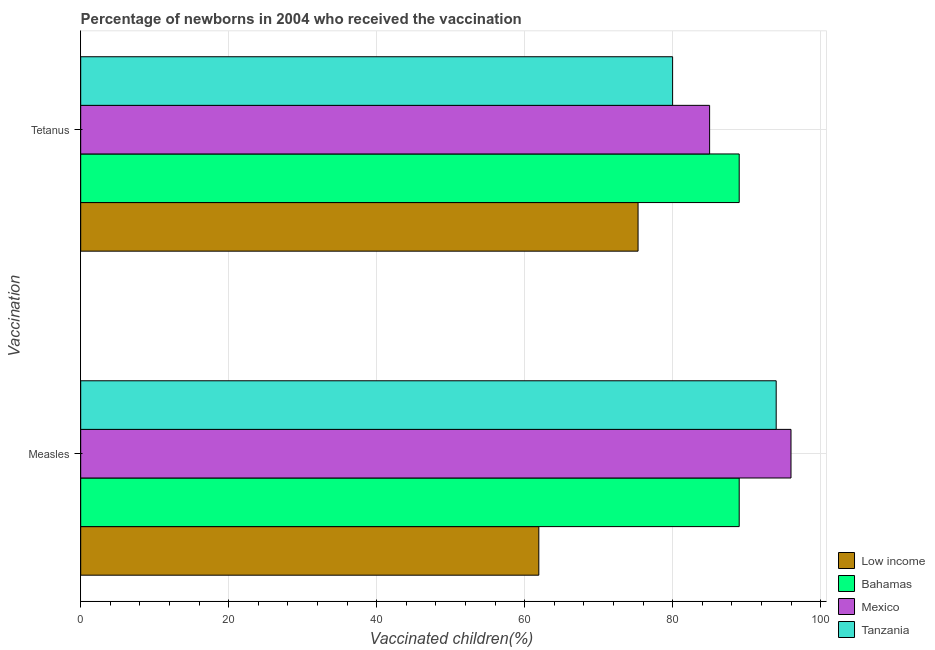How many different coloured bars are there?
Offer a terse response. 4. How many groups of bars are there?
Offer a very short reply. 2. Are the number of bars on each tick of the Y-axis equal?
Offer a terse response. Yes. What is the label of the 1st group of bars from the top?
Keep it short and to the point. Tetanus. What is the percentage of newborns who received vaccination for tetanus in Bahamas?
Give a very brief answer. 89. Across all countries, what is the maximum percentage of newborns who received vaccination for tetanus?
Keep it short and to the point. 89. Across all countries, what is the minimum percentage of newborns who received vaccination for tetanus?
Your answer should be very brief. 75.33. In which country was the percentage of newborns who received vaccination for measles minimum?
Ensure brevity in your answer.  Low income. What is the total percentage of newborns who received vaccination for tetanus in the graph?
Offer a terse response. 329.33. What is the difference between the percentage of newborns who received vaccination for tetanus in Mexico and that in Low income?
Your answer should be compact. 9.67. What is the difference between the percentage of newborns who received vaccination for measles in Mexico and the percentage of newborns who received vaccination for tetanus in Tanzania?
Your answer should be very brief. 16. What is the average percentage of newborns who received vaccination for tetanus per country?
Offer a terse response. 82.33. What is the difference between the percentage of newborns who received vaccination for tetanus and percentage of newborns who received vaccination for measles in Bahamas?
Your answer should be very brief. 0. What is the ratio of the percentage of newborns who received vaccination for measles in Low income to that in Bahamas?
Provide a succinct answer. 0.7. Is the percentage of newborns who received vaccination for tetanus in Low income less than that in Mexico?
Keep it short and to the point. Yes. In how many countries, is the percentage of newborns who received vaccination for tetanus greater than the average percentage of newborns who received vaccination for tetanus taken over all countries?
Offer a very short reply. 2. What does the 1st bar from the top in Tetanus represents?
Your answer should be very brief. Tanzania. What does the 2nd bar from the bottom in Measles represents?
Offer a terse response. Bahamas. How many countries are there in the graph?
Your answer should be compact. 4. What is the difference between two consecutive major ticks on the X-axis?
Your answer should be very brief. 20. Does the graph contain any zero values?
Offer a very short reply. No. Where does the legend appear in the graph?
Your answer should be very brief. Bottom right. How many legend labels are there?
Provide a succinct answer. 4. What is the title of the graph?
Provide a short and direct response. Percentage of newborns in 2004 who received the vaccination. What is the label or title of the X-axis?
Make the answer very short. Vaccinated children(%)
. What is the label or title of the Y-axis?
Provide a succinct answer. Vaccination. What is the Vaccinated children(%)
 in Low income in Measles?
Your answer should be very brief. 61.92. What is the Vaccinated children(%)
 of Bahamas in Measles?
Offer a terse response. 89. What is the Vaccinated children(%)
 in Mexico in Measles?
Your answer should be very brief. 96. What is the Vaccinated children(%)
 in Tanzania in Measles?
Offer a terse response. 94. What is the Vaccinated children(%)
 of Low income in Tetanus?
Provide a succinct answer. 75.33. What is the Vaccinated children(%)
 of Bahamas in Tetanus?
Provide a succinct answer. 89. What is the Vaccinated children(%)
 in Mexico in Tetanus?
Your answer should be very brief. 85. What is the Vaccinated children(%)
 of Tanzania in Tetanus?
Your answer should be very brief. 80. Across all Vaccination, what is the maximum Vaccinated children(%)
 in Low income?
Make the answer very short. 75.33. Across all Vaccination, what is the maximum Vaccinated children(%)
 in Bahamas?
Give a very brief answer. 89. Across all Vaccination, what is the maximum Vaccinated children(%)
 of Mexico?
Provide a short and direct response. 96. Across all Vaccination, what is the maximum Vaccinated children(%)
 in Tanzania?
Provide a short and direct response. 94. Across all Vaccination, what is the minimum Vaccinated children(%)
 of Low income?
Make the answer very short. 61.92. Across all Vaccination, what is the minimum Vaccinated children(%)
 of Bahamas?
Your answer should be compact. 89. Across all Vaccination, what is the minimum Vaccinated children(%)
 in Mexico?
Offer a terse response. 85. What is the total Vaccinated children(%)
 of Low income in the graph?
Give a very brief answer. 137.25. What is the total Vaccinated children(%)
 of Bahamas in the graph?
Provide a succinct answer. 178. What is the total Vaccinated children(%)
 in Mexico in the graph?
Your response must be concise. 181. What is the total Vaccinated children(%)
 in Tanzania in the graph?
Keep it short and to the point. 174. What is the difference between the Vaccinated children(%)
 of Low income in Measles and that in Tetanus?
Your answer should be compact. -13.41. What is the difference between the Vaccinated children(%)
 in Bahamas in Measles and that in Tetanus?
Offer a very short reply. 0. What is the difference between the Vaccinated children(%)
 of Mexico in Measles and that in Tetanus?
Keep it short and to the point. 11. What is the difference between the Vaccinated children(%)
 of Tanzania in Measles and that in Tetanus?
Provide a succinct answer. 14. What is the difference between the Vaccinated children(%)
 in Low income in Measles and the Vaccinated children(%)
 in Bahamas in Tetanus?
Offer a very short reply. -27.08. What is the difference between the Vaccinated children(%)
 in Low income in Measles and the Vaccinated children(%)
 in Mexico in Tetanus?
Give a very brief answer. -23.08. What is the difference between the Vaccinated children(%)
 in Low income in Measles and the Vaccinated children(%)
 in Tanzania in Tetanus?
Ensure brevity in your answer.  -18.08. What is the difference between the Vaccinated children(%)
 in Bahamas in Measles and the Vaccinated children(%)
 in Tanzania in Tetanus?
Your response must be concise. 9. What is the average Vaccinated children(%)
 in Low income per Vaccination?
Make the answer very short. 68.62. What is the average Vaccinated children(%)
 in Bahamas per Vaccination?
Offer a terse response. 89. What is the average Vaccinated children(%)
 of Mexico per Vaccination?
Ensure brevity in your answer.  90.5. What is the difference between the Vaccinated children(%)
 of Low income and Vaccinated children(%)
 of Bahamas in Measles?
Offer a terse response. -27.08. What is the difference between the Vaccinated children(%)
 in Low income and Vaccinated children(%)
 in Mexico in Measles?
Offer a terse response. -34.08. What is the difference between the Vaccinated children(%)
 in Low income and Vaccinated children(%)
 in Tanzania in Measles?
Provide a short and direct response. -32.08. What is the difference between the Vaccinated children(%)
 in Bahamas and Vaccinated children(%)
 in Mexico in Measles?
Offer a very short reply. -7. What is the difference between the Vaccinated children(%)
 of Mexico and Vaccinated children(%)
 of Tanzania in Measles?
Your answer should be very brief. 2. What is the difference between the Vaccinated children(%)
 in Low income and Vaccinated children(%)
 in Bahamas in Tetanus?
Offer a very short reply. -13.67. What is the difference between the Vaccinated children(%)
 of Low income and Vaccinated children(%)
 of Mexico in Tetanus?
Ensure brevity in your answer.  -9.67. What is the difference between the Vaccinated children(%)
 of Low income and Vaccinated children(%)
 of Tanzania in Tetanus?
Your answer should be compact. -4.67. What is the difference between the Vaccinated children(%)
 in Bahamas and Vaccinated children(%)
 in Mexico in Tetanus?
Your answer should be compact. 4. What is the ratio of the Vaccinated children(%)
 in Low income in Measles to that in Tetanus?
Provide a short and direct response. 0.82. What is the ratio of the Vaccinated children(%)
 in Bahamas in Measles to that in Tetanus?
Your answer should be compact. 1. What is the ratio of the Vaccinated children(%)
 of Mexico in Measles to that in Tetanus?
Your response must be concise. 1.13. What is the ratio of the Vaccinated children(%)
 of Tanzania in Measles to that in Tetanus?
Offer a very short reply. 1.18. What is the difference between the highest and the second highest Vaccinated children(%)
 in Low income?
Your answer should be very brief. 13.41. What is the difference between the highest and the second highest Vaccinated children(%)
 in Bahamas?
Provide a short and direct response. 0. What is the difference between the highest and the lowest Vaccinated children(%)
 in Low income?
Give a very brief answer. 13.41. What is the difference between the highest and the lowest Vaccinated children(%)
 of Mexico?
Offer a terse response. 11. 